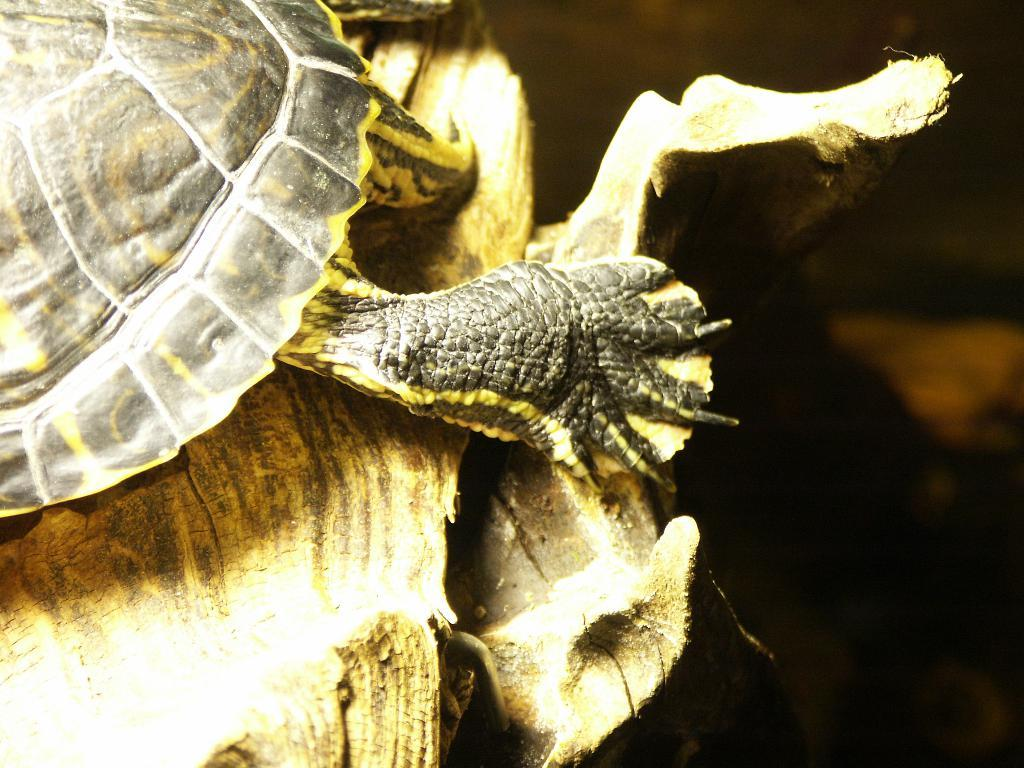What is there is a wooden object on the left side of the image, what can you tell me about it? There is a wooden object on the left side of the image, and it has a tortoise on it. Can you describe the tortoise in the image? The tortoise is on the wooden object in the image. What is the background of the image like? The background of the image is blurred. Can you tell me what time the clock shows in the image? There is no clock present in the image. What type of bone can be seen in the image? There is no bone present in the image. 